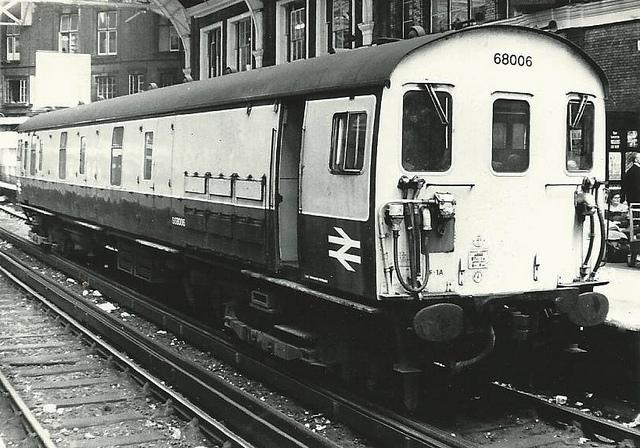What number is the largest number on the train? Please explain your reasoning. eight. The number is 8. 